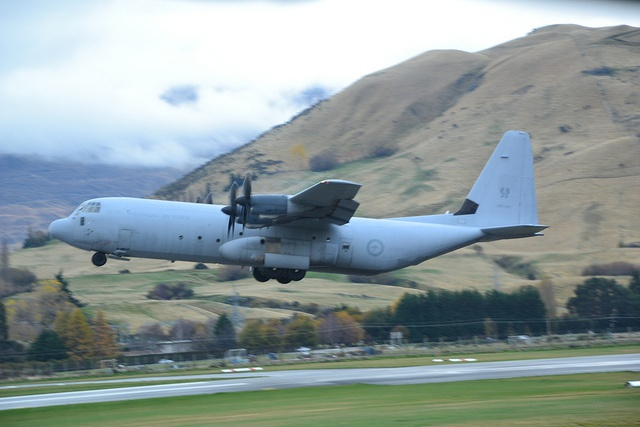Describe the objects in this image and their specific colors. I can see a airplane in lightblue, blue, and gray tones in this image. 